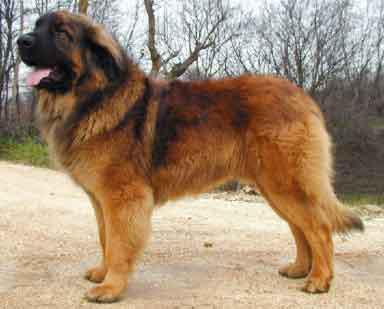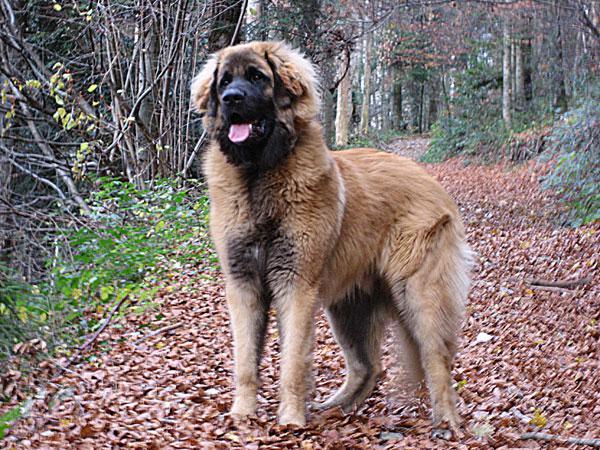The first image is the image on the left, the second image is the image on the right. Examine the images to the left and right. Is the description "There is one dog sitting in one image." accurate? Answer yes or no. No. The first image is the image on the left, the second image is the image on the right. Examine the images to the left and right. Is the description "At least one image shows two mammals." accurate? Answer yes or no. No. 